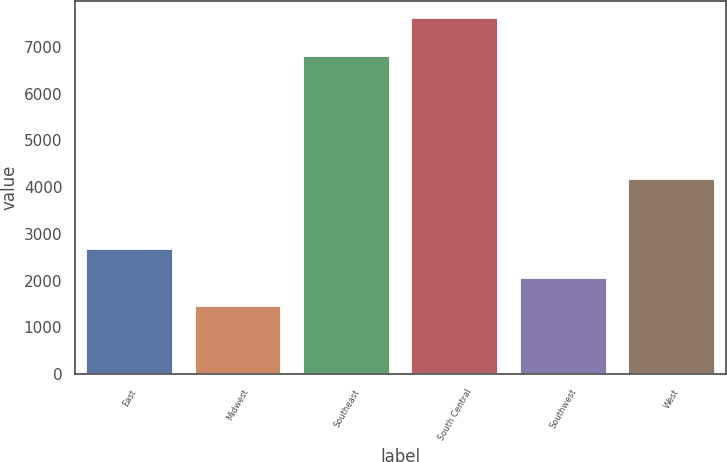Convert chart. <chart><loc_0><loc_0><loc_500><loc_500><bar_chart><fcel>East<fcel>Midwest<fcel>Southeast<fcel>South Central<fcel>Southwest<fcel>West<nl><fcel>2681<fcel>1449<fcel>6807<fcel>7609<fcel>2065<fcel>4180<nl></chart> 